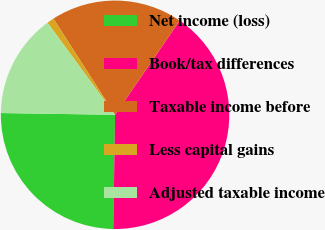<chart> <loc_0><loc_0><loc_500><loc_500><pie_chart><fcel>Net income (loss)<fcel>Book/tax differences<fcel>Taxable income before<fcel>Less capital gains<fcel>Adjusted taxable income<nl><fcel>25.0%<fcel>40.68%<fcel>18.65%<fcel>1.0%<fcel>14.68%<nl></chart> 